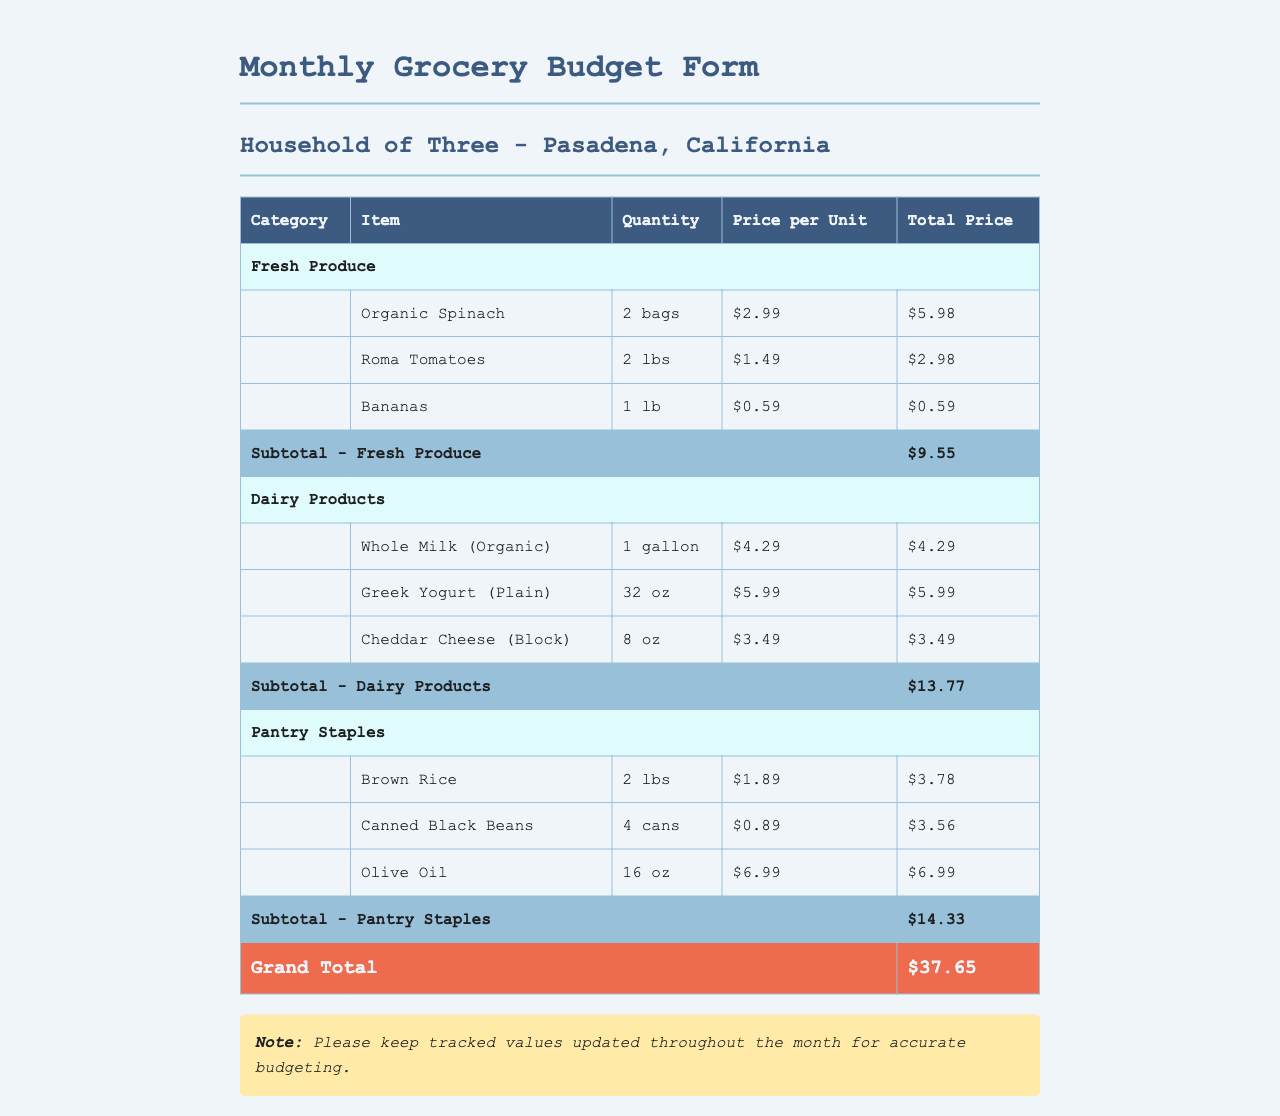What is the grand total for the grocery budget? The grand total is the sum of all categorized subtotals, which is $9.55 + $13.77 + $14.33 = $37.65.
Answer: $37.65 How many bags of organic spinach are included? The document states the quantity of organic spinach specified which is 2 bags.
Answer: 2 bags What is the price per unit of Greek yogurt? The document lists the price per unit for Greek yogurt as $5.99.
Answer: $5.99 What is the subtotal for dairy products? The subtotal for dairy products is calculated from the items listed under that category, totaling $13.77.
Answer: $13.77 How many cans of black beans are budgeted for? The document specifies the budgeted quantity of canned black beans as 4 cans.
Answer: 4 cans What type of cheese is listed under dairy products? The document identifies the type of cheese listed, which is Cheddar Cheese.
Answer: Cheddar Cheese What category does olive oil belong to? The document categorizes olive oil under pantry staples.
Answer: Pantry Staples What is the total price for bananas? The total price for bananas is specified in the document as $0.59.
Answer: $0.59 What type of document is this? This document is a Monthly Grocery Budget Form specifically for a household of three in Pasadena, California.
Answer: Monthly Grocery Budget Form 